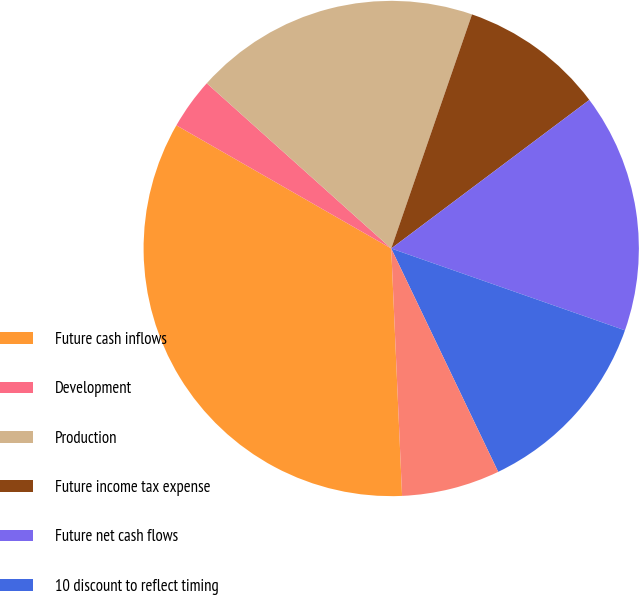Convert chart to OTSL. <chart><loc_0><loc_0><loc_500><loc_500><pie_chart><fcel>Future cash inflows<fcel>Development<fcel>Production<fcel>Future income tax expense<fcel>Future net cash flows<fcel>10 discount to reflect timing<fcel>Standardized measure of<nl><fcel>33.98%<fcel>3.34%<fcel>18.66%<fcel>9.47%<fcel>15.6%<fcel>12.53%<fcel>6.41%<nl></chart> 